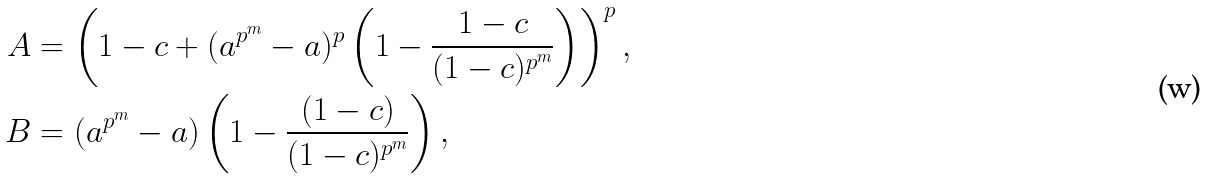Convert formula to latex. <formula><loc_0><loc_0><loc_500><loc_500>A & = \left ( 1 - c + ( a ^ { p ^ { m } } - a ) ^ { p } \left ( 1 - \frac { 1 - c } { ( 1 - c ) ^ { p ^ { m } } } \right ) \right ) ^ { p } , \\ B & = ( a ^ { p ^ { m } } - a ) \left ( 1 - \frac { ( 1 - c ) } { ( 1 - c ) ^ { p ^ { m } } } \right ) ,</formula> 